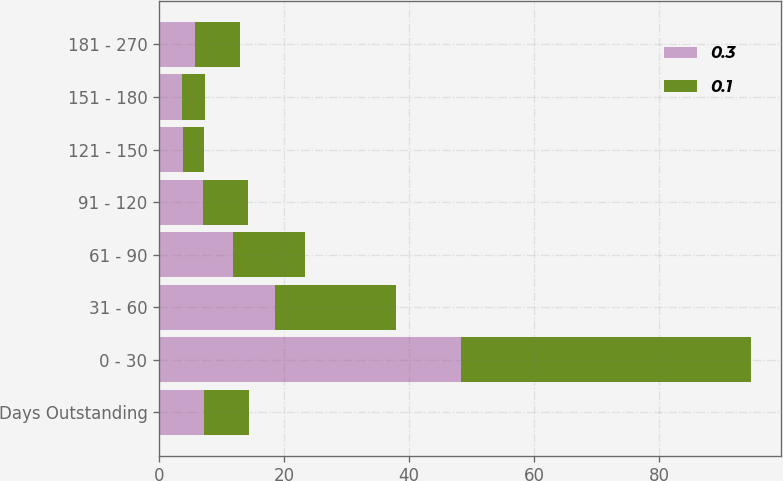<chart> <loc_0><loc_0><loc_500><loc_500><stacked_bar_chart><ecel><fcel>Days Outstanding<fcel>0 - 30<fcel>31 - 60<fcel>61 - 90<fcel>91 - 120<fcel>121 - 150<fcel>151 - 180<fcel>181 - 270<nl><fcel>0.3<fcel>7.2<fcel>48.4<fcel>18.6<fcel>11.9<fcel>7.1<fcel>3.8<fcel>3.6<fcel>5.7<nl><fcel>0.1<fcel>7.2<fcel>46.4<fcel>19.3<fcel>11.5<fcel>7.1<fcel>3.4<fcel>3.8<fcel>7.3<nl></chart> 